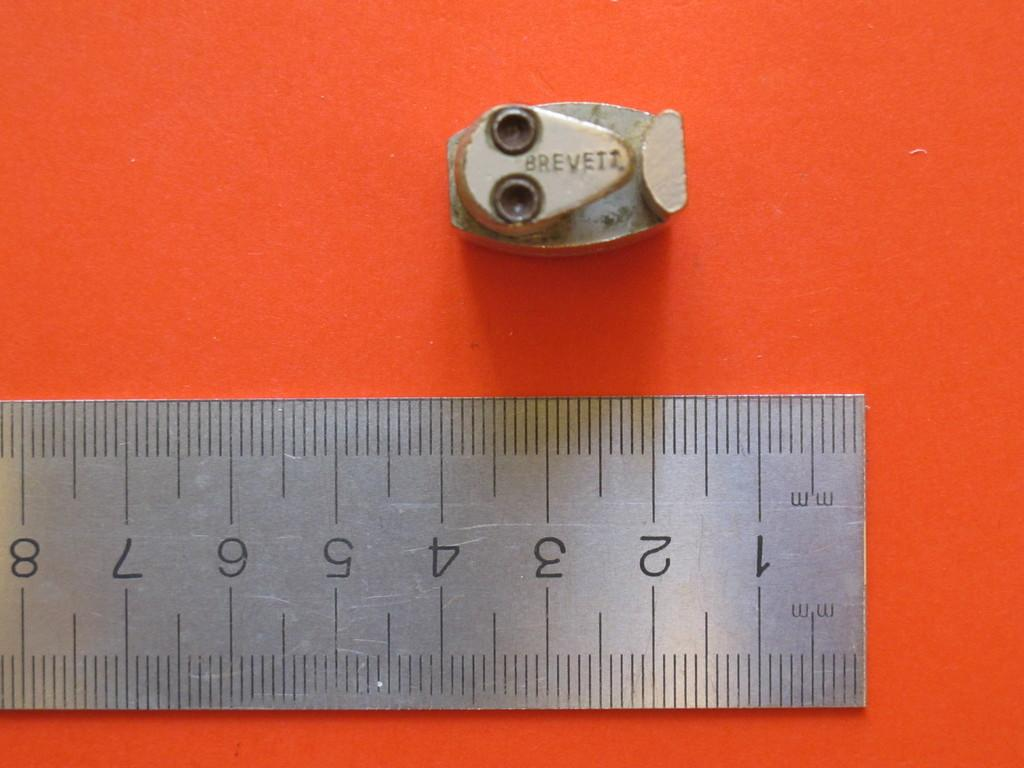<image>
Write a terse but informative summary of the picture. A small metal piece that says Breveii on it sits next to a metal ruler. 